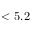<formula> <loc_0><loc_0><loc_500><loc_500>< 5 . 2</formula> 